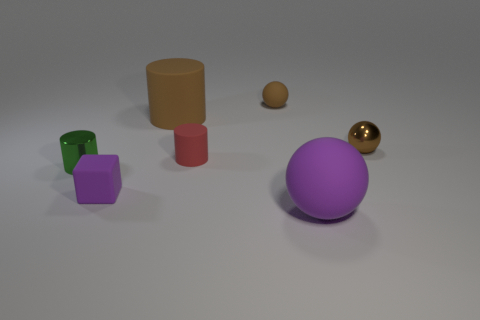Add 1 brown cylinders. How many objects exist? 8 Subtract all cubes. How many objects are left? 6 Subtract 0 blue spheres. How many objects are left? 7 Subtract all red cylinders. Subtract all small red matte cylinders. How many objects are left? 5 Add 6 big rubber spheres. How many big rubber spheres are left? 7 Add 3 big gray rubber cubes. How many big gray rubber cubes exist? 3 